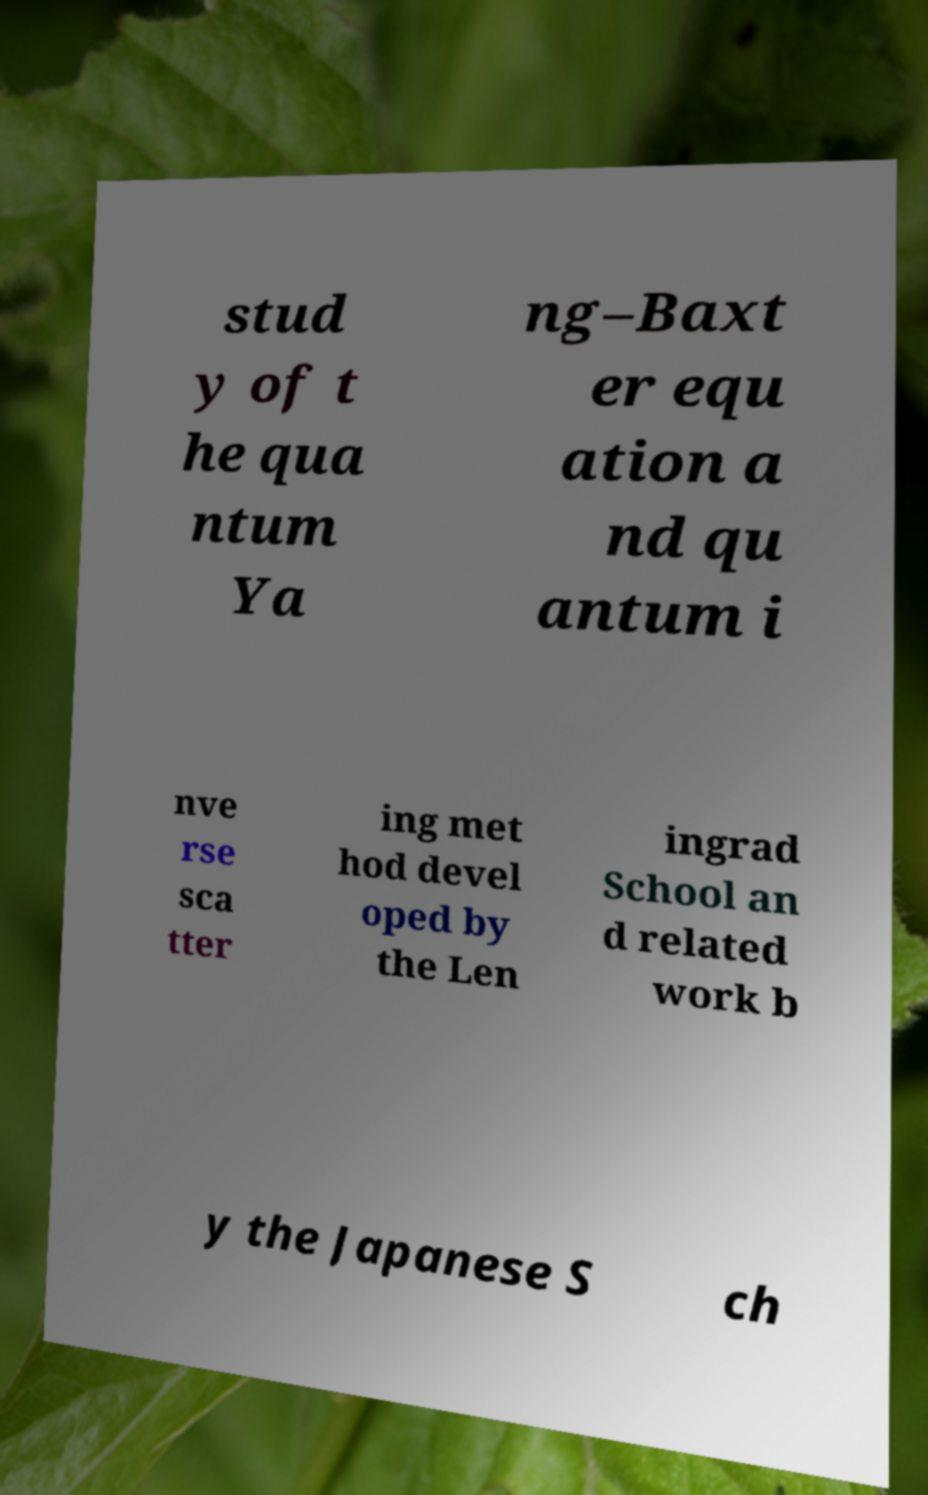Please identify and transcribe the text found in this image. stud y of t he qua ntum Ya ng–Baxt er equ ation a nd qu antum i nve rse sca tter ing met hod devel oped by the Len ingrad School an d related work b y the Japanese S ch 